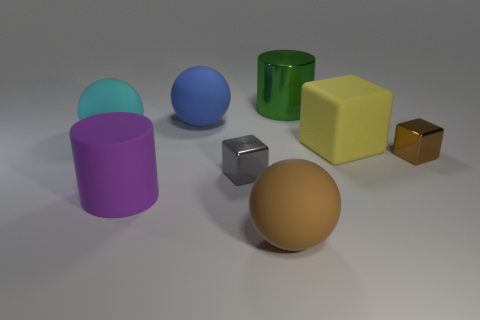Is the number of cyan objects greater than the number of small blue objects?
Make the answer very short. Yes. The large cylinder that is behind the big purple rubber thing is what color?
Your answer should be very brief. Green. What is the size of the metallic thing that is right of the gray object and in front of the cyan rubber ball?
Your answer should be compact. Small. What number of gray metallic blocks have the same size as the green cylinder?
Make the answer very short. 0. There is a brown object that is the same shape as the cyan matte thing; what is it made of?
Give a very brief answer. Rubber. Do the large green metallic object and the large purple matte thing have the same shape?
Your answer should be compact. Yes. There is a large purple cylinder; what number of small blocks are in front of it?
Keep it short and to the point. 0. What is the shape of the brown thing behind the metallic object in front of the tiny brown metal object?
Ensure brevity in your answer.  Cube. The purple object that is the same material as the yellow object is what shape?
Your answer should be very brief. Cylinder. There is a sphere on the left side of the purple matte cylinder; is its size the same as the metallic block on the right side of the big yellow rubber block?
Offer a very short reply. No. 